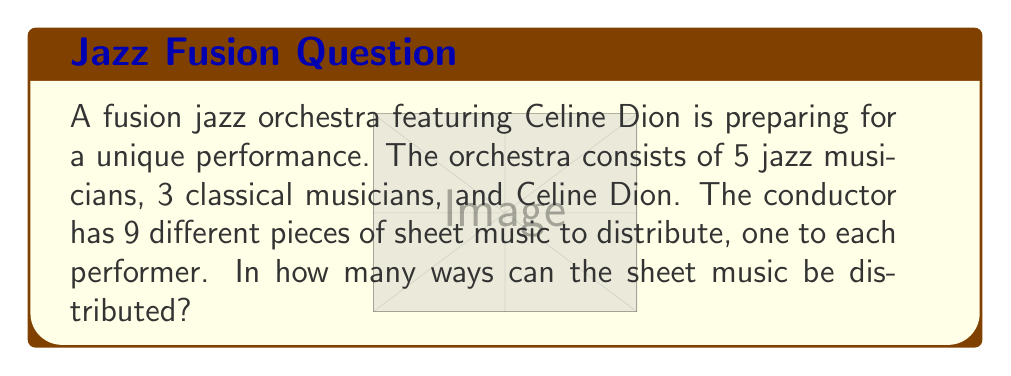What is the answer to this math problem? Let's approach this step-by-step:

1) This is a permutation problem. We are arranging 9 distinct items (pieces of sheet music) among 9 distinct positions (performers).

2) The order matters in this case, as each piece of sheet music is unique and each performer is distinct.

3) When we have n distinct objects to arrange in n distinct positions, we use the permutation formula:

   $$P(n,n) = n!$$

4) In this case, n = 9 (9 pieces of sheet music and 9 performers)

5) Therefore, the number of ways to distribute the sheet music is:

   $$9! = 9 \times 8 \times 7 \times 6 \times 5 \times 4 \times 3 \times 2 \times 1$$

6) Calculating this out:

   $$9! = 362,880$$

Thus, there are 362,880 ways to distribute the sheet music.
Answer: 362,880 